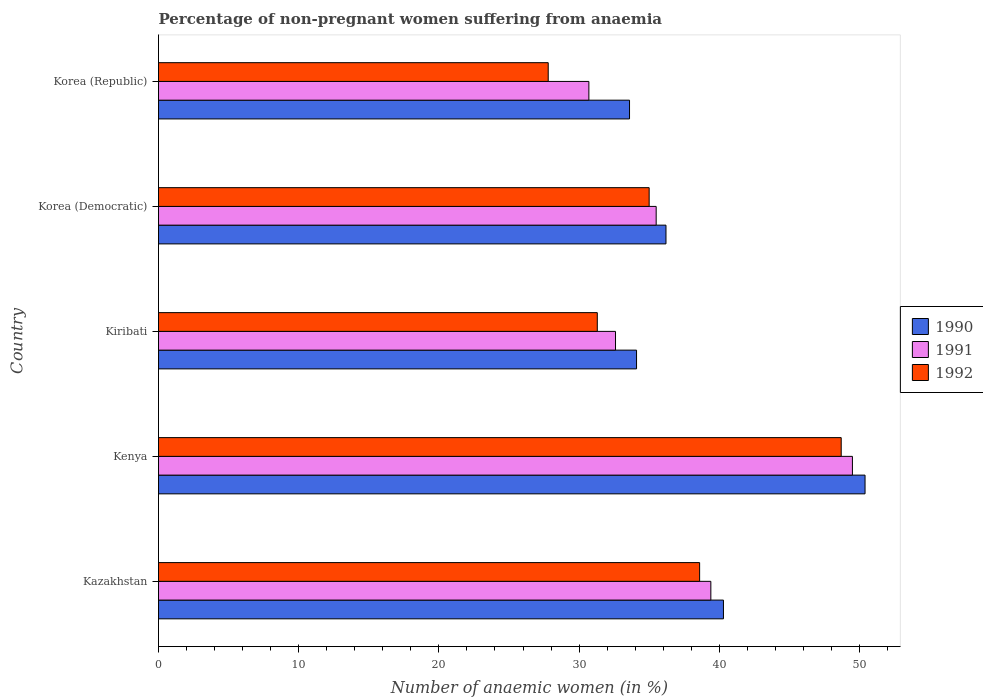Are the number of bars per tick equal to the number of legend labels?
Offer a terse response. Yes. Are the number of bars on each tick of the Y-axis equal?
Offer a very short reply. Yes. How many bars are there on the 3rd tick from the top?
Offer a terse response. 3. How many bars are there on the 3rd tick from the bottom?
Offer a very short reply. 3. What is the label of the 4th group of bars from the top?
Offer a very short reply. Kenya. What is the percentage of non-pregnant women suffering from anaemia in 1991 in Kiribati?
Offer a terse response. 32.6. Across all countries, what is the maximum percentage of non-pregnant women suffering from anaemia in 1991?
Offer a terse response. 49.5. Across all countries, what is the minimum percentage of non-pregnant women suffering from anaemia in 1992?
Ensure brevity in your answer.  27.8. In which country was the percentage of non-pregnant women suffering from anaemia in 1990 maximum?
Provide a succinct answer. Kenya. What is the total percentage of non-pregnant women suffering from anaemia in 1991 in the graph?
Ensure brevity in your answer.  187.7. What is the difference between the percentage of non-pregnant women suffering from anaemia in 1992 in Kenya and that in Korea (Democratic)?
Your response must be concise. 13.7. What is the difference between the percentage of non-pregnant women suffering from anaemia in 1992 in Korea (Democratic) and the percentage of non-pregnant women suffering from anaemia in 1990 in Kenya?
Give a very brief answer. -15.4. What is the average percentage of non-pregnant women suffering from anaemia in 1992 per country?
Offer a terse response. 36.28. What is the difference between the percentage of non-pregnant women suffering from anaemia in 1990 and percentage of non-pregnant women suffering from anaemia in 1991 in Kenya?
Your answer should be compact. 0.9. What is the ratio of the percentage of non-pregnant women suffering from anaemia in 1990 in Kenya to that in Kiribati?
Offer a terse response. 1.48. Is the difference between the percentage of non-pregnant women suffering from anaemia in 1990 in Kazakhstan and Kenya greater than the difference between the percentage of non-pregnant women suffering from anaemia in 1991 in Kazakhstan and Kenya?
Offer a terse response. No. What is the difference between the highest and the second highest percentage of non-pregnant women suffering from anaemia in 1992?
Give a very brief answer. 10.1. What does the 1st bar from the bottom in Kazakhstan represents?
Offer a terse response. 1990. What is the difference between two consecutive major ticks on the X-axis?
Your response must be concise. 10. Does the graph contain any zero values?
Offer a terse response. No. Where does the legend appear in the graph?
Make the answer very short. Center right. What is the title of the graph?
Your answer should be very brief. Percentage of non-pregnant women suffering from anaemia. Does "2007" appear as one of the legend labels in the graph?
Make the answer very short. No. What is the label or title of the X-axis?
Offer a terse response. Number of anaemic women (in %). What is the Number of anaemic women (in %) of 1990 in Kazakhstan?
Ensure brevity in your answer.  40.3. What is the Number of anaemic women (in %) in 1991 in Kazakhstan?
Offer a very short reply. 39.4. What is the Number of anaemic women (in %) in 1992 in Kazakhstan?
Offer a terse response. 38.6. What is the Number of anaemic women (in %) in 1990 in Kenya?
Your answer should be compact. 50.4. What is the Number of anaemic women (in %) of 1991 in Kenya?
Your answer should be compact. 49.5. What is the Number of anaemic women (in %) in 1992 in Kenya?
Provide a short and direct response. 48.7. What is the Number of anaemic women (in %) of 1990 in Kiribati?
Your answer should be compact. 34.1. What is the Number of anaemic women (in %) in 1991 in Kiribati?
Provide a short and direct response. 32.6. What is the Number of anaemic women (in %) in 1992 in Kiribati?
Your answer should be compact. 31.3. What is the Number of anaemic women (in %) of 1990 in Korea (Democratic)?
Your response must be concise. 36.2. What is the Number of anaemic women (in %) in 1991 in Korea (Democratic)?
Your answer should be very brief. 35.5. What is the Number of anaemic women (in %) in 1992 in Korea (Democratic)?
Your answer should be very brief. 35. What is the Number of anaemic women (in %) in 1990 in Korea (Republic)?
Offer a terse response. 33.6. What is the Number of anaemic women (in %) in 1991 in Korea (Republic)?
Ensure brevity in your answer.  30.7. What is the Number of anaemic women (in %) in 1992 in Korea (Republic)?
Keep it short and to the point. 27.8. Across all countries, what is the maximum Number of anaemic women (in %) in 1990?
Offer a terse response. 50.4. Across all countries, what is the maximum Number of anaemic women (in %) of 1991?
Provide a succinct answer. 49.5. Across all countries, what is the maximum Number of anaemic women (in %) of 1992?
Your response must be concise. 48.7. Across all countries, what is the minimum Number of anaemic women (in %) of 1990?
Give a very brief answer. 33.6. Across all countries, what is the minimum Number of anaemic women (in %) in 1991?
Offer a terse response. 30.7. Across all countries, what is the minimum Number of anaemic women (in %) in 1992?
Your answer should be very brief. 27.8. What is the total Number of anaemic women (in %) in 1990 in the graph?
Your response must be concise. 194.6. What is the total Number of anaemic women (in %) of 1991 in the graph?
Your response must be concise. 187.7. What is the total Number of anaemic women (in %) of 1992 in the graph?
Give a very brief answer. 181.4. What is the difference between the Number of anaemic women (in %) in 1990 in Kazakhstan and that in Kenya?
Your response must be concise. -10.1. What is the difference between the Number of anaemic women (in %) of 1991 in Kazakhstan and that in Kenya?
Your answer should be compact. -10.1. What is the difference between the Number of anaemic women (in %) of 1990 in Kazakhstan and that in Kiribati?
Provide a succinct answer. 6.2. What is the difference between the Number of anaemic women (in %) of 1991 in Kazakhstan and that in Kiribati?
Offer a very short reply. 6.8. What is the difference between the Number of anaemic women (in %) in 1990 in Kazakhstan and that in Korea (Democratic)?
Ensure brevity in your answer.  4.1. What is the difference between the Number of anaemic women (in %) in 1991 in Kazakhstan and that in Korea (Democratic)?
Ensure brevity in your answer.  3.9. What is the difference between the Number of anaemic women (in %) of 1990 in Kazakhstan and that in Korea (Republic)?
Offer a terse response. 6.7. What is the difference between the Number of anaemic women (in %) in 1991 in Kazakhstan and that in Korea (Republic)?
Offer a terse response. 8.7. What is the difference between the Number of anaemic women (in %) of 1991 in Kenya and that in Kiribati?
Your answer should be compact. 16.9. What is the difference between the Number of anaemic women (in %) of 1992 in Kenya and that in Kiribati?
Your response must be concise. 17.4. What is the difference between the Number of anaemic women (in %) of 1990 in Kenya and that in Korea (Democratic)?
Offer a very short reply. 14.2. What is the difference between the Number of anaemic women (in %) in 1991 in Kenya and that in Korea (Democratic)?
Provide a succinct answer. 14. What is the difference between the Number of anaemic women (in %) in 1992 in Kenya and that in Korea (Democratic)?
Provide a succinct answer. 13.7. What is the difference between the Number of anaemic women (in %) of 1990 in Kenya and that in Korea (Republic)?
Ensure brevity in your answer.  16.8. What is the difference between the Number of anaemic women (in %) of 1991 in Kenya and that in Korea (Republic)?
Offer a terse response. 18.8. What is the difference between the Number of anaemic women (in %) in 1992 in Kenya and that in Korea (Republic)?
Offer a terse response. 20.9. What is the difference between the Number of anaemic women (in %) in 1992 in Kiribati and that in Korea (Democratic)?
Your answer should be very brief. -3.7. What is the difference between the Number of anaemic women (in %) in 1990 in Kiribati and that in Korea (Republic)?
Make the answer very short. 0.5. What is the difference between the Number of anaemic women (in %) of 1991 in Kiribati and that in Korea (Republic)?
Your answer should be very brief. 1.9. What is the difference between the Number of anaemic women (in %) of 1992 in Kiribati and that in Korea (Republic)?
Make the answer very short. 3.5. What is the difference between the Number of anaemic women (in %) of 1990 in Kazakhstan and the Number of anaemic women (in %) of 1991 in Kenya?
Provide a succinct answer. -9.2. What is the difference between the Number of anaemic women (in %) in 1990 in Kazakhstan and the Number of anaemic women (in %) in 1992 in Kenya?
Ensure brevity in your answer.  -8.4. What is the difference between the Number of anaemic women (in %) of 1991 in Kazakhstan and the Number of anaemic women (in %) of 1992 in Kenya?
Your response must be concise. -9.3. What is the difference between the Number of anaemic women (in %) in 1990 in Kazakhstan and the Number of anaemic women (in %) in 1991 in Kiribati?
Keep it short and to the point. 7.7. What is the difference between the Number of anaemic women (in %) of 1991 in Kazakhstan and the Number of anaemic women (in %) of 1992 in Kiribati?
Provide a short and direct response. 8.1. What is the difference between the Number of anaemic women (in %) of 1990 in Kazakhstan and the Number of anaemic women (in %) of 1992 in Korea (Democratic)?
Offer a terse response. 5.3. What is the difference between the Number of anaemic women (in %) of 1991 in Kazakhstan and the Number of anaemic women (in %) of 1992 in Korea (Democratic)?
Keep it short and to the point. 4.4. What is the difference between the Number of anaemic women (in %) in 1990 in Kazakhstan and the Number of anaemic women (in %) in 1991 in Korea (Republic)?
Your answer should be very brief. 9.6. What is the difference between the Number of anaemic women (in %) of 1990 in Kazakhstan and the Number of anaemic women (in %) of 1992 in Korea (Republic)?
Offer a terse response. 12.5. What is the difference between the Number of anaemic women (in %) of 1990 in Kenya and the Number of anaemic women (in %) of 1991 in Kiribati?
Provide a succinct answer. 17.8. What is the difference between the Number of anaemic women (in %) in 1990 in Kenya and the Number of anaemic women (in %) in 1991 in Korea (Democratic)?
Your answer should be compact. 14.9. What is the difference between the Number of anaemic women (in %) in 1990 in Kenya and the Number of anaemic women (in %) in 1992 in Korea (Democratic)?
Ensure brevity in your answer.  15.4. What is the difference between the Number of anaemic women (in %) in 1991 in Kenya and the Number of anaemic women (in %) in 1992 in Korea (Democratic)?
Make the answer very short. 14.5. What is the difference between the Number of anaemic women (in %) in 1990 in Kenya and the Number of anaemic women (in %) in 1992 in Korea (Republic)?
Your response must be concise. 22.6. What is the difference between the Number of anaemic women (in %) in 1991 in Kenya and the Number of anaemic women (in %) in 1992 in Korea (Republic)?
Keep it short and to the point. 21.7. What is the difference between the Number of anaemic women (in %) in 1990 in Kiribati and the Number of anaemic women (in %) in 1991 in Korea (Democratic)?
Give a very brief answer. -1.4. What is the difference between the Number of anaemic women (in %) of 1990 in Kiribati and the Number of anaemic women (in %) of 1992 in Korea (Democratic)?
Your response must be concise. -0.9. What is the difference between the Number of anaemic women (in %) of 1991 in Kiribati and the Number of anaemic women (in %) of 1992 in Korea (Democratic)?
Ensure brevity in your answer.  -2.4. What is the difference between the Number of anaemic women (in %) of 1990 in Kiribati and the Number of anaemic women (in %) of 1992 in Korea (Republic)?
Your response must be concise. 6.3. What is the difference between the Number of anaemic women (in %) in 1991 in Kiribati and the Number of anaemic women (in %) in 1992 in Korea (Republic)?
Ensure brevity in your answer.  4.8. What is the difference between the Number of anaemic women (in %) in 1990 in Korea (Democratic) and the Number of anaemic women (in %) in 1991 in Korea (Republic)?
Your answer should be very brief. 5.5. What is the difference between the Number of anaemic women (in %) of 1990 in Korea (Democratic) and the Number of anaemic women (in %) of 1992 in Korea (Republic)?
Provide a succinct answer. 8.4. What is the difference between the Number of anaemic women (in %) of 1991 in Korea (Democratic) and the Number of anaemic women (in %) of 1992 in Korea (Republic)?
Provide a short and direct response. 7.7. What is the average Number of anaemic women (in %) of 1990 per country?
Your answer should be very brief. 38.92. What is the average Number of anaemic women (in %) of 1991 per country?
Offer a very short reply. 37.54. What is the average Number of anaemic women (in %) in 1992 per country?
Offer a terse response. 36.28. What is the difference between the Number of anaemic women (in %) of 1990 and Number of anaemic women (in %) of 1992 in Kazakhstan?
Offer a terse response. 1.7. What is the difference between the Number of anaemic women (in %) of 1991 and Number of anaemic women (in %) of 1992 in Kenya?
Make the answer very short. 0.8. What is the difference between the Number of anaemic women (in %) in 1990 and Number of anaemic women (in %) in 1992 in Kiribati?
Provide a short and direct response. 2.8. What is the difference between the Number of anaemic women (in %) in 1991 and Number of anaemic women (in %) in 1992 in Kiribati?
Give a very brief answer. 1.3. What is the difference between the Number of anaemic women (in %) in 1991 and Number of anaemic women (in %) in 1992 in Korea (Democratic)?
Keep it short and to the point. 0.5. What is the difference between the Number of anaemic women (in %) of 1990 and Number of anaemic women (in %) of 1992 in Korea (Republic)?
Your response must be concise. 5.8. What is the difference between the Number of anaemic women (in %) in 1991 and Number of anaemic women (in %) in 1992 in Korea (Republic)?
Provide a succinct answer. 2.9. What is the ratio of the Number of anaemic women (in %) of 1990 in Kazakhstan to that in Kenya?
Offer a very short reply. 0.8. What is the ratio of the Number of anaemic women (in %) of 1991 in Kazakhstan to that in Kenya?
Provide a succinct answer. 0.8. What is the ratio of the Number of anaemic women (in %) of 1992 in Kazakhstan to that in Kenya?
Make the answer very short. 0.79. What is the ratio of the Number of anaemic women (in %) in 1990 in Kazakhstan to that in Kiribati?
Ensure brevity in your answer.  1.18. What is the ratio of the Number of anaemic women (in %) in 1991 in Kazakhstan to that in Kiribati?
Offer a very short reply. 1.21. What is the ratio of the Number of anaemic women (in %) in 1992 in Kazakhstan to that in Kiribati?
Ensure brevity in your answer.  1.23. What is the ratio of the Number of anaemic women (in %) of 1990 in Kazakhstan to that in Korea (Democratic)?
Your answer should be compact. 1.11. What is the ratio of the Number of anaemic women (in %) of 1991 in Kazakhstan to that in Korea (Democratic)?
Provide a short and direct response. 1.11. What is the ratio of the Number of anaemic women (in %) of 1992 in Kazakhstan to that in Korea (Democratic)?
Your answer should be very brief. 1.1. What is the ratio of the Number of anaemic women (in %) of 1990 in Kazakhstan to that in Korea (Republic)?
Provide a succinct answer. 1.2. What is the ratio of the Number of anaemic women (in %) of 1991 in Kazakhstan to that in Korea (Republic)?
Provide a succinct answer. 1.28. What is the ratio of the Number of anaemic women (in %) in 1992 in Kazakhstan to that in Korea (Republic)?
Keep it short and to the point. 1.39. What is the ratio of the Number of anaemic women (in %) of 1990 in Kenya to that in Kiribati?
Keep it short and to the point. 1.48. What is the ratio of the Number of anaemic women (in %) of 1991 in Kenya to that in Kiribati?
Keep it short and to the point. 1.52. What is the ratio of the Number of anaemic women (in %) of 1992 in Kenya to that in Kiribati?
Offer a terse response. 1.56. What is the ratio of the Number of anaemic women (in %) of 1990 in Kenya to that in Korea (Democratic)?
Keep it short and to the point. 1.39. What is the ratio of the Number of anaemic women (in %) of 1991 in Kenya to that in Korea (Democratic)?
Keep it short and to the point. 1.39. What is the ratio of the Number of anaemic women (in %) in 1992 in Kenya to that in Korea (Democratic)?
Ensure brevity in your answer.  1.39. What is the ratio of the Number of anaemic women (in %) in 1991 in Kenya to that in Korea (Republic)?
Provide a short and direct response. 1.61. What is the ratio of the Number of anaemic women (in %) of 1992 in Kenya to that in Korea (Republic)?
Make the answer very short. 1.75. What is the ratio of the Number of anaemic women (in %) of 1990 in Kiribati to that in Korea (Democratic)?
Your response must be concise. 0.94. What is the ratio of the Number of anaemic women (in %) of 1991 in Kiribati to that in Korea (Democratic)?
Your answer should be compact. 0.92. What is the ratio of the Number of anaemic women (in %) in 1992 in Kiribati to that in Korea (Democratic)?
Offer a terse response. 0.89. What is the ratio of the Number of anaemic women (in %) in 1990 in Kiribati to that in Korea (Republic)?
Your answer should be very brief. 1.01. What is the ratio of the Number of anaemic women (in %) of 1991 in Kiribati to that in Korea (Republic)?
Offer a terse response. 1.06. What is the ratio of the Number of anaemic women (in %) of 1992 in Kiribati to that in Korea (Republic)?
Your answer should be compact. 1.13. What is the ratio of the Number of anaemic women (in %) of 1990 in Korea (Democratic) to that in Korea (Republic)?
Offer a very short reply. 1.08. What is the ratio of the Number of anaemic women (in %) of 1991 in Korea (Democratic) to that in Korea (Republic)?
Your response must be concise. 1.16. What is the ratio of the Number of anaemic women (in %) in 1992 in Korea (Democratic) to that in Korea (Republic)?
Keep it short and to the point. 1.26. What is the difference between the highest and the second highest Number of anaemic women (in %) in 1992?
Offer a very short reply. 10.1. What is the difference between the highest and the lowest Number of anaemic women (in %) in 1990?
Your answer should be very brief. 16.8. What is the difference between the highest and the lowest Number of anaemic women (in %) in 1992?
Your answer should be compact. 20.9. 